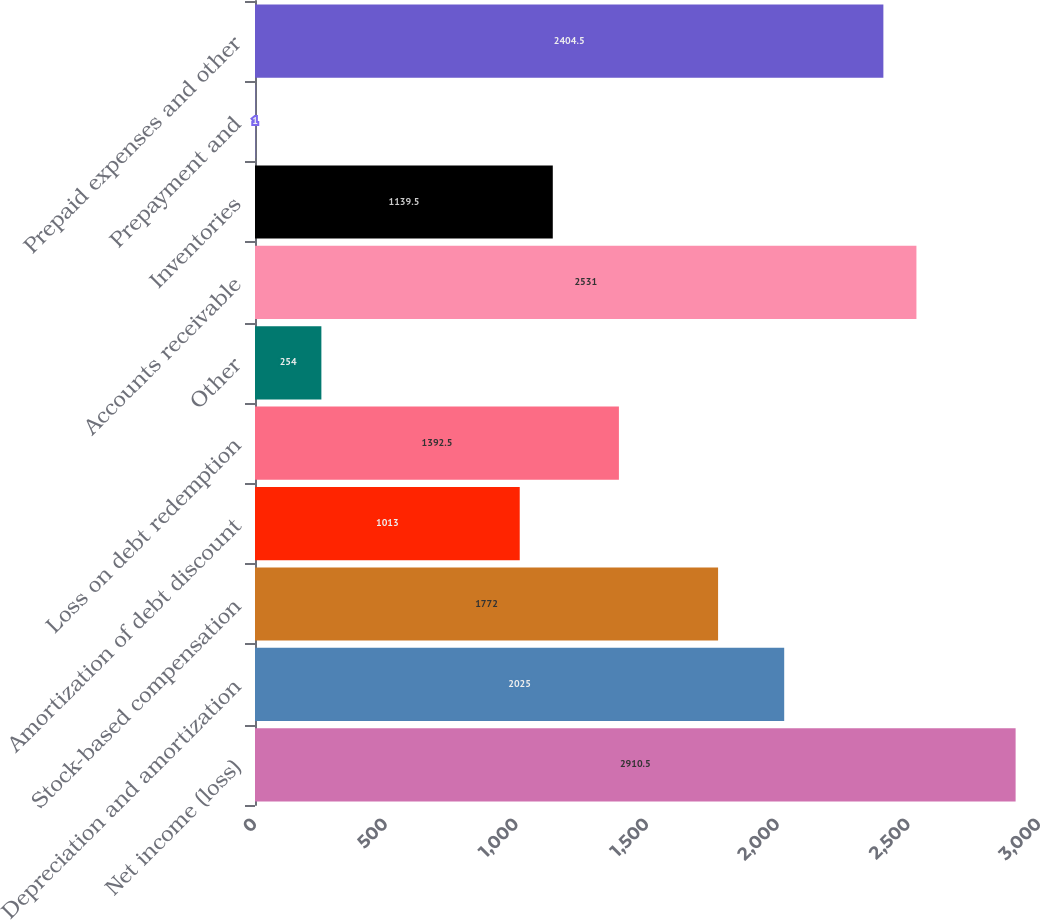Convert chart to OTSL. <chart><loc_0><loc_0><loc_500><loc_500><bar_chart><fcel>Net income (loss)<fcel>Depreciation and amortization<fcel>Stock-based compensation<fcel>Amortization of debt discount<fcel>Loss on debt redemption<fcel>Other<fcel>Accounts receivable<fcel>Inventories<fcel>Prepayment and<fcel>Prepaid expenses and other<nl><fcel>2910.5<fcel>2025<fcel>1772<fcel>1013<fcel>1392.5<fcel>254<fcel>2531<fcel>1139.5<fcel>1<fcel>2404.5<nl></chart> 